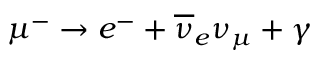Convert formula to latex. <formula><loc_0><loc_0><loc_500><loc_500>\mu ^ { - } \rightarrow e ^ { - } + \overline { \nu } _ { e } \nu _ { \mu } + \gamma</formula> 